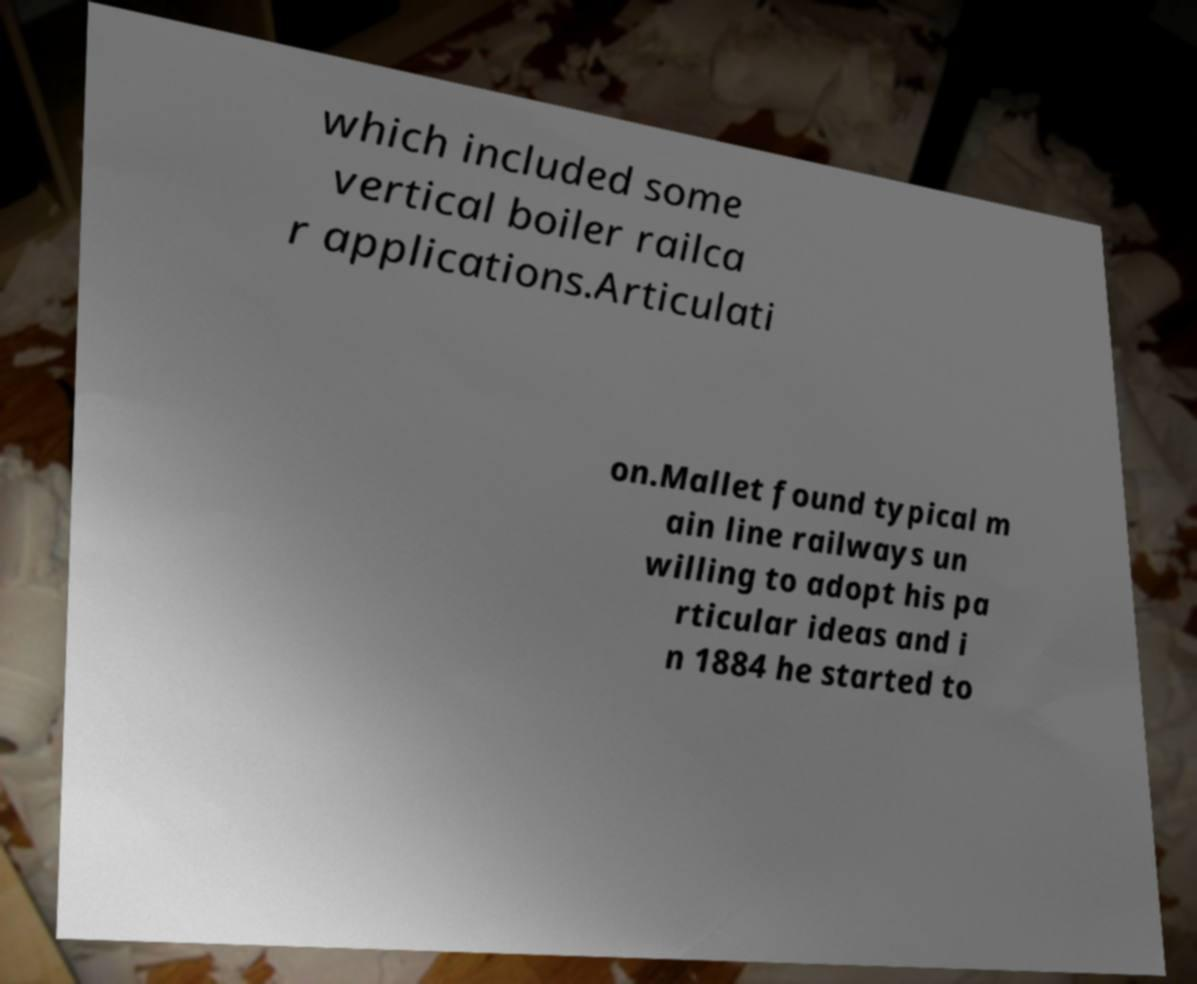For documentation purposes, I need the text within this image transcribed. Could you provide that? which included some vertical boiler railca r applications.Articulati on.Mallet found typical m ain line railways un willing to adopt his pa rticular ideas and i n 1884 he started to 